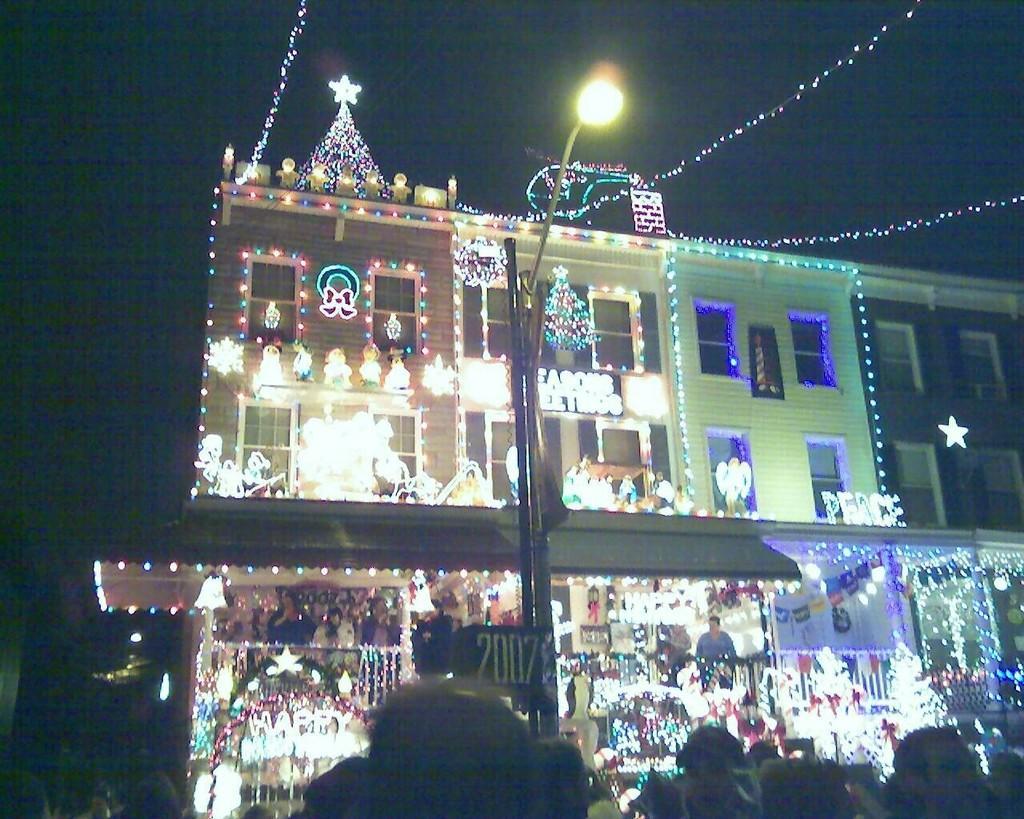In one or two sentences, can you explain what this image depicts? In this picture I can see there is a building and it is arranged with lights and there is a pole and there is a light. The building has windows and the sky is dark. 